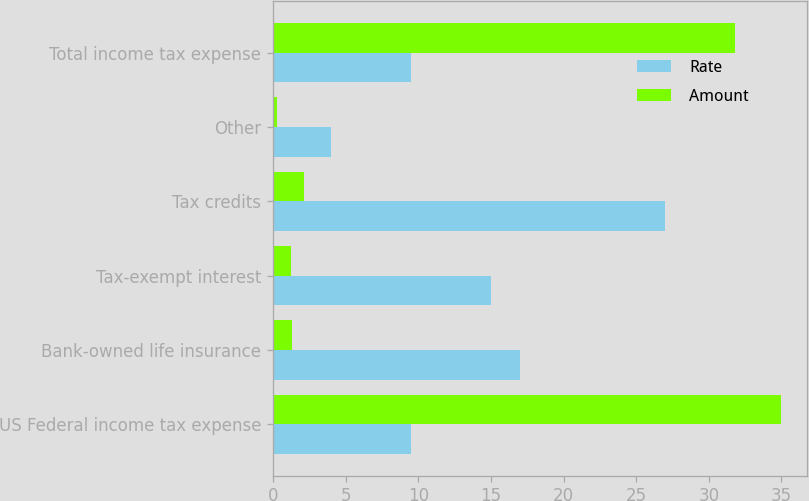Convert chart to OTSL. <chart><loc_0><loc_0><loc_500><loc_500><stacked_bar_chart><ecel><fcel>US Federal income tax expense<fcel>Bank-owned life insurance<fcel>Tax-exempt interest<fcel>Tax credits<fcel>Other<fcel>Total income tax expense<nl><fcel>Rate<fcel>9.5<fcel>17<fcel>15<fcel>27<fcel>4<fcel>9.5<nl><fcel>Amount<fcel>35<fcel>1.3<fcel>1.2<fcel>2.1<fcel>0.3<fcel>31.8<nl></chart> 